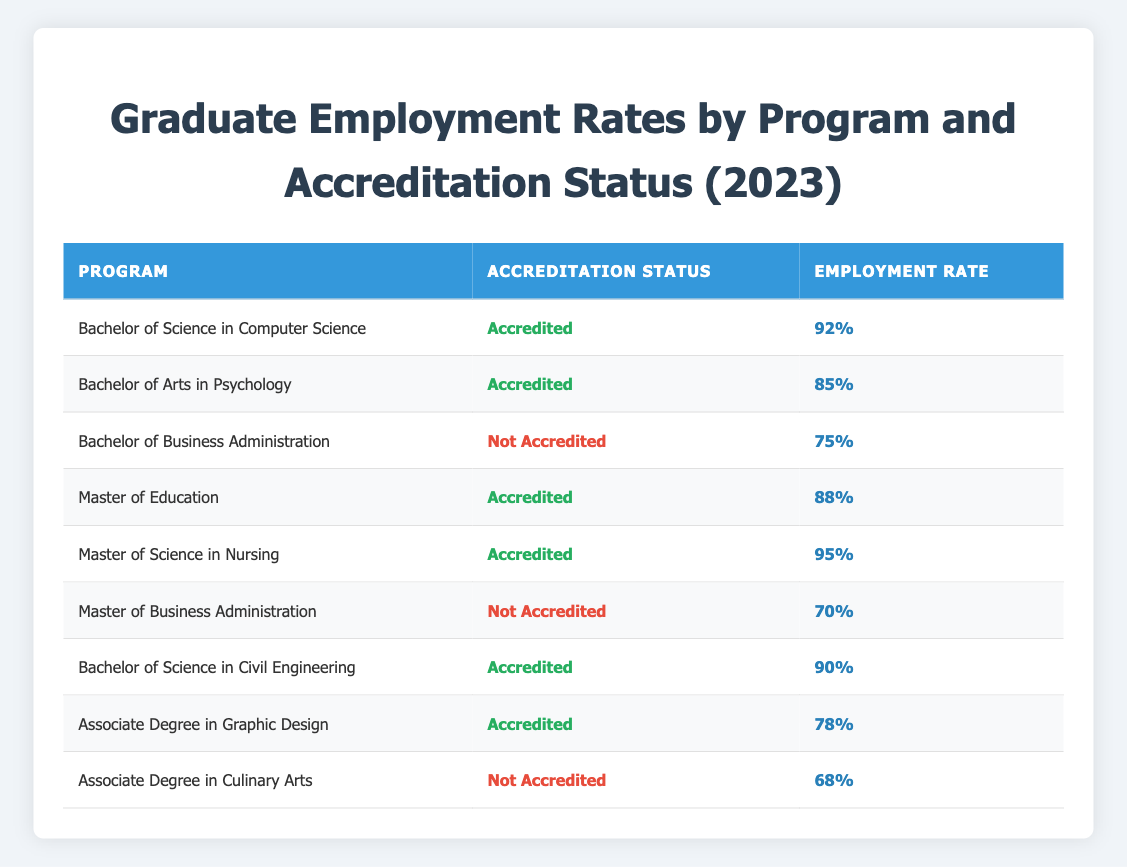What is the employment rate for the Bachelor of Science in Computer Science program? The table indicates that the employment rate for the Bachelor of Science in Computer Science program is listed as 92% under the accredited category.
Answer: 92% Which program has the highest employment rate among those listed? From the table, the program with the highest employment rate is the Master of Science in Nursing, which shows an employment rate of 95%.
Answer: 95% Is the Bachelor of Business Administration program accredited? According to the table, the Bachelor of Business Administration program is classified under the "Not Accredited" status.
Answer: No Calculate the average employment rate for accredited programs. To find the average, we take the employment rates of all accredited programs: 92% (Computer Science), 85% (Psychology), 88% (Education), 95% (Nursing), 90% (Civil Engineering), and 78% (Graphic Design). The sum is 528%, and there are 6 accredited programs. So, the average is 528% / 6 = 88%.
Answer: 88% Do non-accredited programs have lower employment rates than accredited programs? In the table, the employment rates for non-accredited programs are 75% (Bachelor of Business Administration), 70% (Master of Business Administration), and 68% (Culinary Arts). The highest accredited program rate is 95%. Comparing the maximums shows that the highest non-accredited rate (75%) is lower than the lowest accredited rate (78%). Thus, non-accredited programs generally have lower rates.
Answer: Yes How many programs have an employment rate above 80%? From the table, we identify the programs with rates above 80%: Computer Science (92%), Psychology (85%), Education (88%), Nursing (95%), and Civil Engineering (90%). This totals 5 programs.
Answer: 5 What is the employment rate difference between the highest and lowest employment rates for all programs? The highest employment rate in the table is 95% (Nursing), and the lowest is 68% (Culinary Arts). The difference is calculated as 95% - 68% = 27%.
Answer: 27% Are all accredited programs showing an employment rate above 75%? The table shows all accredited programs with employment rates of 92% (Computer Science), 85% (Psychology), 88% (Education), 95% (Nursing), 90% (Civil Engineering), and 78% (Graphic Design). Since all rates exceed 75%, yes, they all show above 75%.
Answer: Yes 